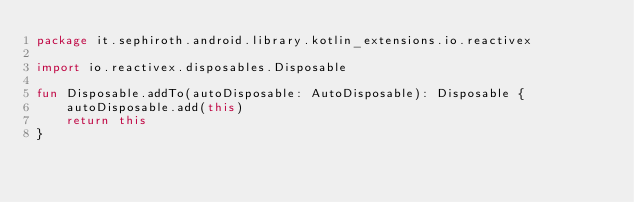<code> <loc_0><loc_0><loc_500><loc_500><_Kotlin_>package it.sephiroth.android.library.kotlin_extensions.io.reactivex

import io.reactivex.disposables.Disposable

fun Disposable.addTo(autoDisposable: AutoDisposable): Disposable {
    autoDisposable.add(this)
    return this
}</code> 